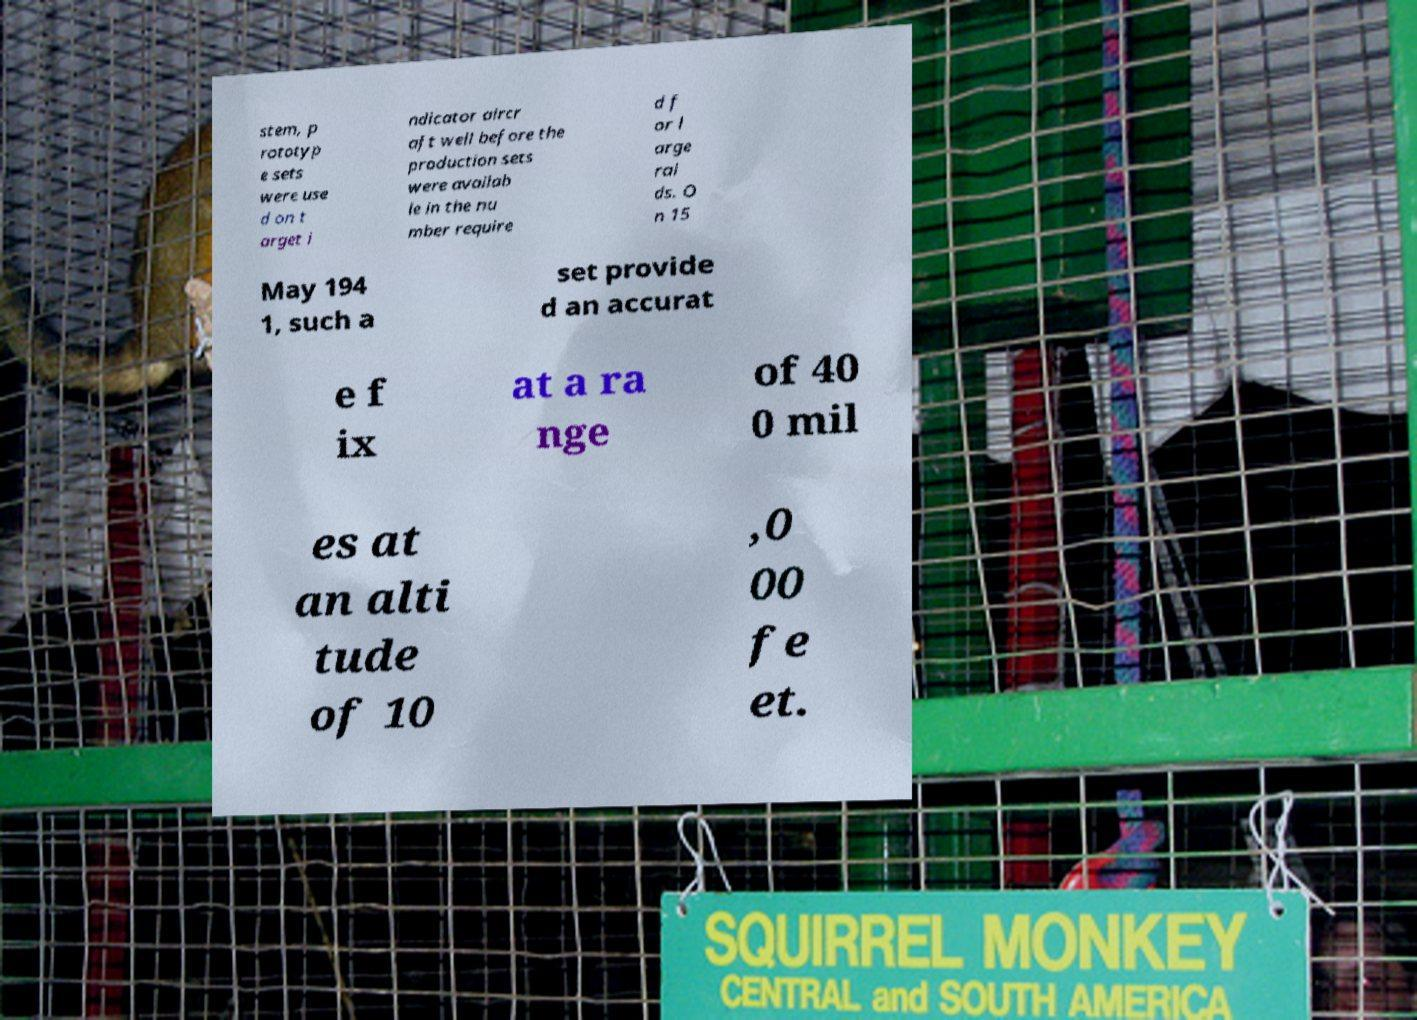Can you accurately transcribe the text from the provided image for me? stem, p rototyp e sets were use d on t arget i ndicator aircr aft well before the production sets were availab le in the nu mber require d f or l arge rai ds. O n 15 May 194 1, such a set provide d an accurat e f ix at a ra nge of 40 0 mil es at an alti tude of 10 ,0 00 fe et. 